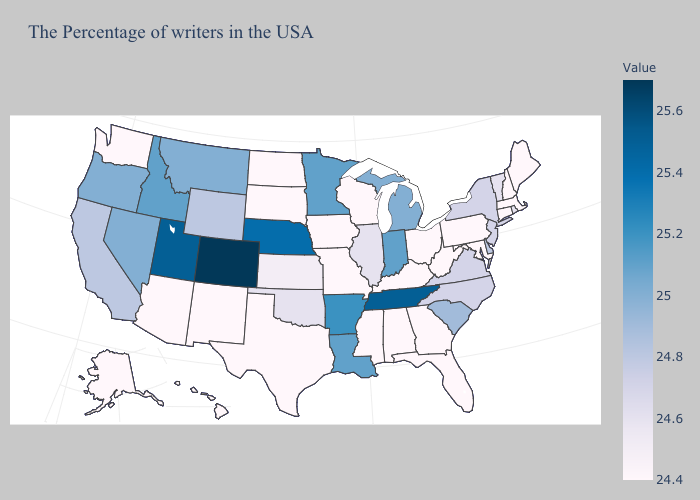Does Montana have a higher value than Arkansas?
Be succinct. No. Does Wyoming have the highest value in the West?
Write a very short answer. No. Among the states that border Tennessee , which have the highest value?
Give a very brief answer. Arkansas. Is the legend a continuous bar?
Short answer required. Yes. Among the states that border Wyoming , does Utah have the lowest value?
Be succinct. No. 